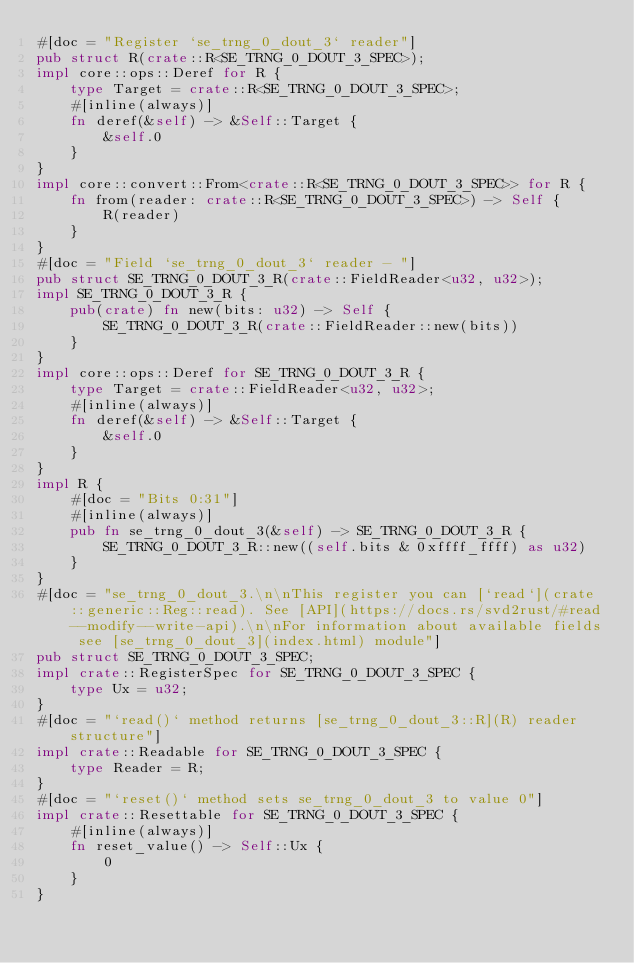Convert code to text. <code><loc_0><loc_0><loc_500><loc_500><_Rust_>#[doc = "Register `se_trng_0_dout_3` reader"]
pub struct R(crate::R<SE_TRNG_0_DOUT_3_SPEC>);
impl core::ops::Deref for R {
    type Target = crate::R<SE_TRNG_0_DOUT_3_SPEC>;
    #[inline(always)]
    fn deref(&self) -> &Self::Target {
        &self.0
    }
}
impl core::convert::From<crate::R<SE_TRNG_0_DOUT_3_SPEC>> for R {
    fn from(reader: crate::R<SE_TRNG_0_DOUT_3_SPEC>) -> Self {
        R(reader)
    }
}
#[doc = "Field `se_trng_0_dout_3` reader - "]
pub struct SE_TRNG_0_DOUT_3_R(crate::FieldReader<u32, u32>);
impl SE_TRNG_0_DOUT_3_R {
    pub(crate) fn new(bits: u32) -> Self {
        SE_TRNG_0_DOUT_3_R(crate::FieldReader::new(bits))
    }
}
impl core::ops::Deref for SE_TRNG_0_DOUT_3_R {
    type Target = crate::FieldReader<u32, u32>;
    #[inline(always)]
    fn deref(&self) -> &Self::Target {
        &self.0
    }
}
impl R {
    #[doc = "Bits 0:31"]
    #[inline(always)]
    pub fn se_trng_0_dout_3(&self) -> SE_TRNG_0_DOUT_3_R {
        SE_TRNG_0_DOUT_3_R::new((self.bits & 0xffff_ffff) as u32)
    }
}
#[doc = "se_trng_0_dout_3.\n\nThis register you can [`read`](crate::generic::Reg::read). See [API](https://docs.rs/svd2rust/#read--modify--write-api).\n\nFor information about available fields see [se_trng_0_dout_3](index.html) module"]
pub struct SE_TRNG_0_DOUT_3_SPEC;
impl crate::RegisterSpec for SE_TRNG_0_DOUT_3_SPEC {
    type Ux = u32;
}
#[doc = "`read()` method returns [se_trng_0_dout_3::R](R) reader structure"]
impl crate::Readable for SE_TRNG_0_DOUT_3_SPEC {
    type Reader = R;
}
#[doc = "`reset()` method sets se_trng_0_dout_3 to value 0"]
impl crate::Resettable for SE_TRNG_0_DOUT_3_SPEC {
    #[inline(always)]
    fn reset_value() -> Self::Ux {
        0
    }
}
</code> 